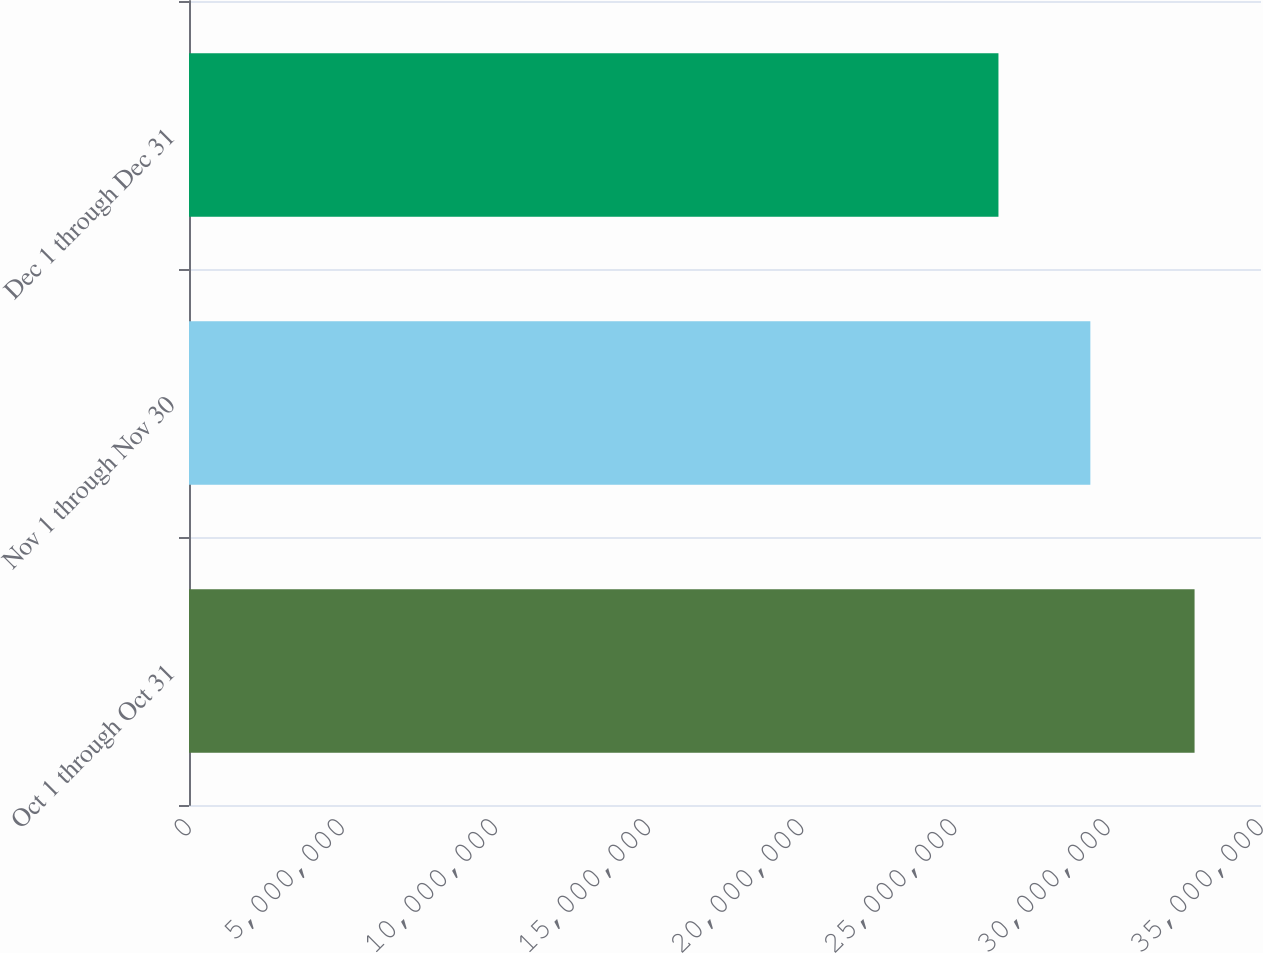<chart> <loc_0><loc_0><loc_500><loc_500><bar_chart><fcel>Oct 1 through Oct 31<fcel>Nov 1 through Nov 30<fcel>Dec 1 through Dec 31<nl><fcel>3.2831e+07<fcel>2.94288e+07<fcel>2.64281e+07<nl></chart> 